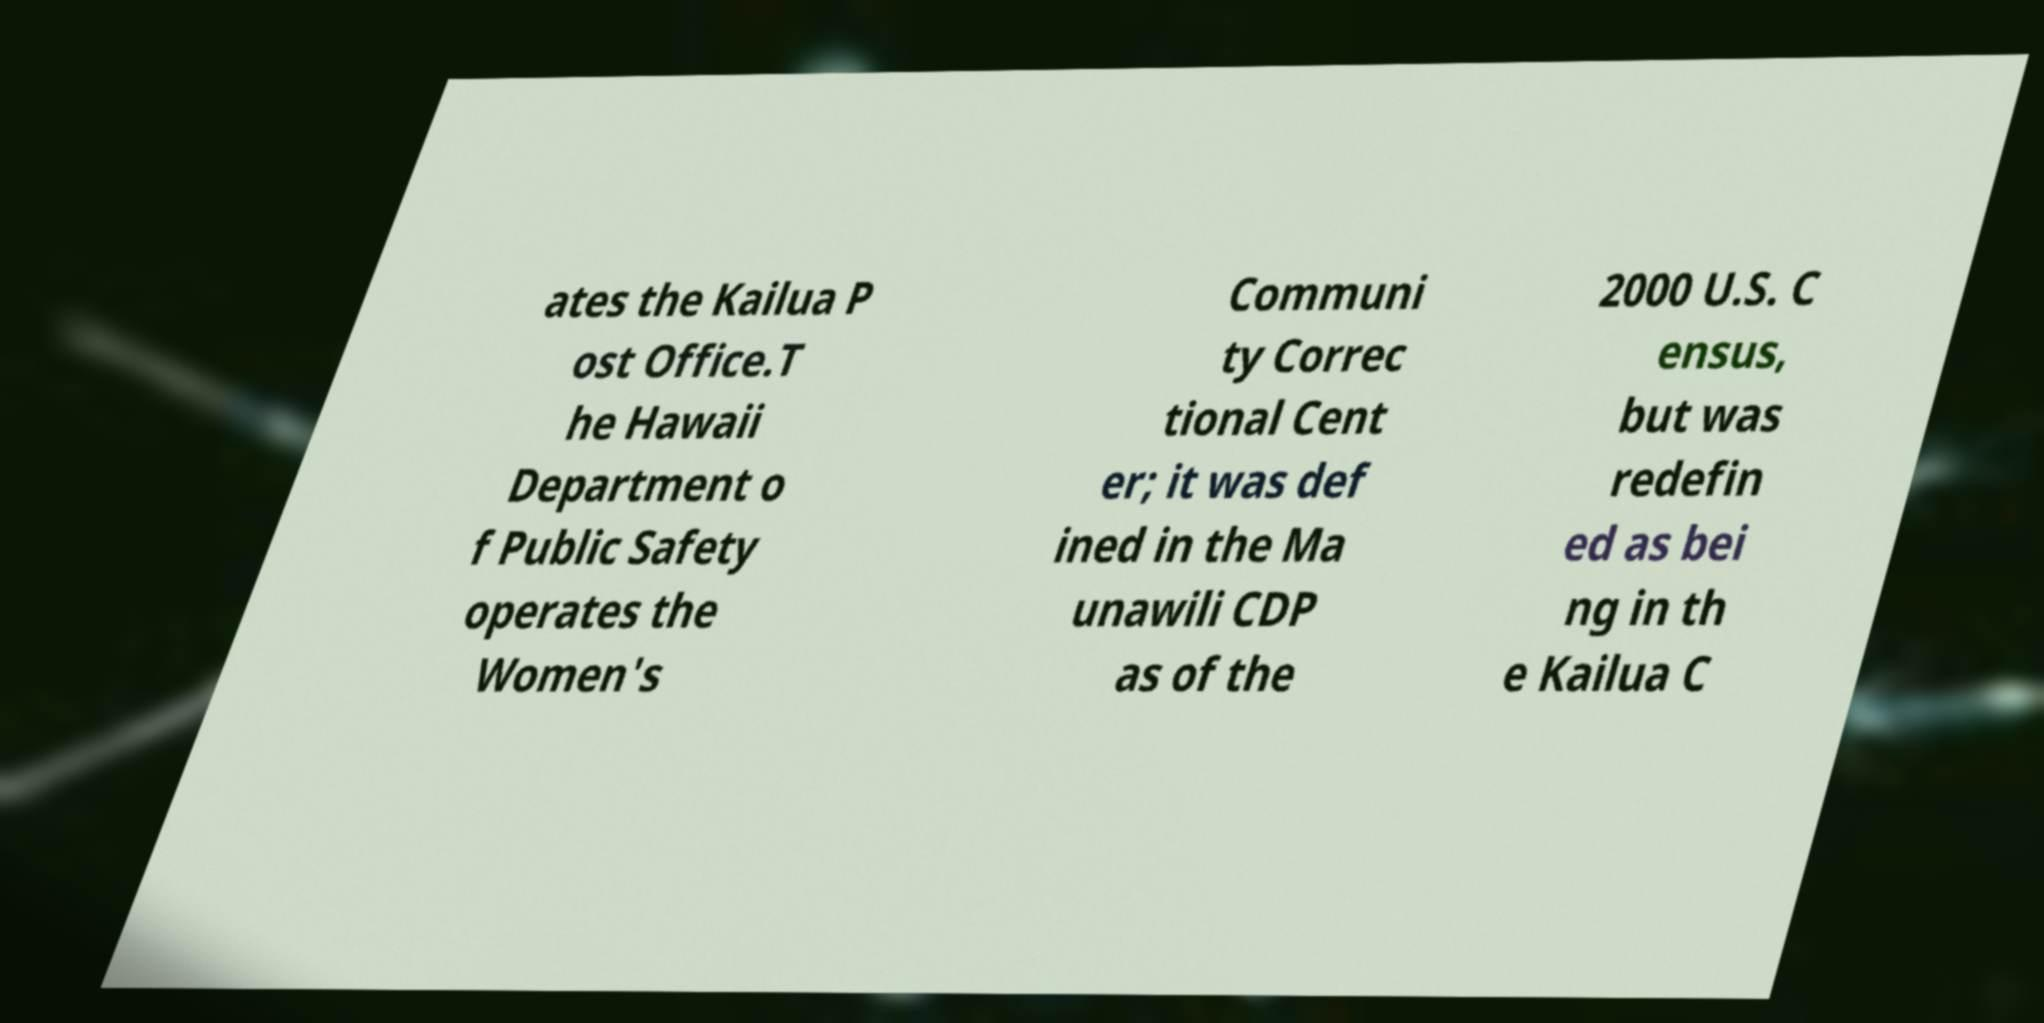Could you assist in decoding the text presented in this image and type it out clearly? ates the Kailua P ost Office.T he Hawaii Department o f Public Safety operates the Women's Communi ty Correc tional Cent er; it was def ined in the Ma unawili CDP as of the 2000 U.S. C ensus, but was redefin ed as bei ng in th e Kailua C 